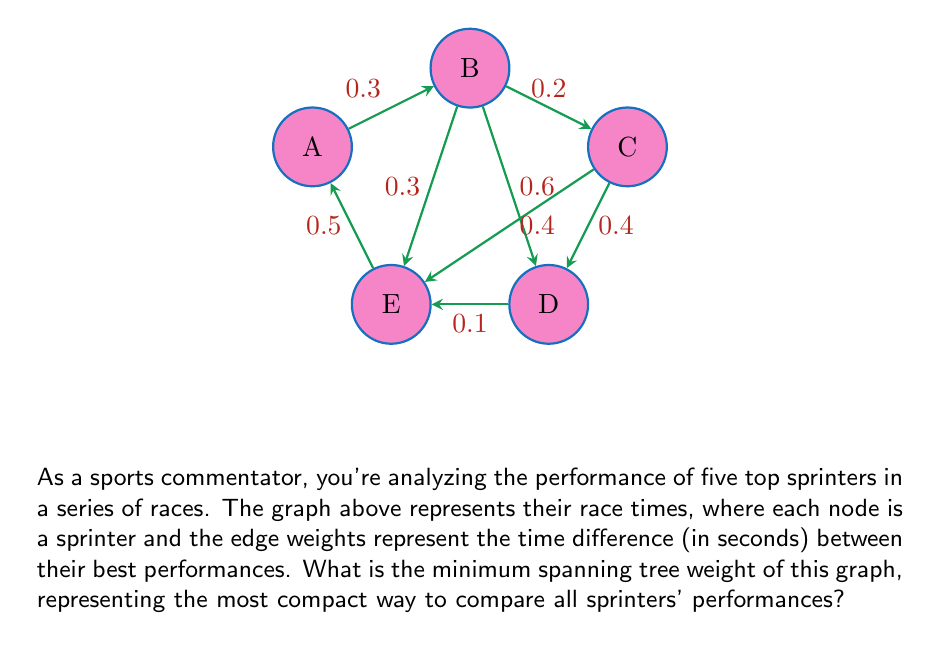Provide a solution to this math problem. To find the minimum spanning tree (MST) weight, we'll use Kruskal's algorithm:

1) Sort edges by weight:
   D-E (0.1), B-C (0.2), A-B (0.3), B-E (0.3), C-D (0.4), C-E (0.4), E-A (0.5), B-D (0.6)

2) Add edges to the MST, avoiding cycles:
   - Add D-E (0.1)
   - Add B-C (0.2)
   - Add A-B (0.3)
   - Skip B-E (would create cycle)
   - Add C-D (0.4)

3) The MST is complete with 4 edges (n-1 where n=5 sprinters).

4) Sum the weights of the MST edges:
   $$0.1 + 0.2 + 0.3 + 0.4 = 1.0$$

The MST weight of 1.0 represents the most efficient way to compare all sprinters' best times, minimizing the total time differences considered while ensuring all sprinters are connected in the comparison.
Answer: 1.0 seconds 